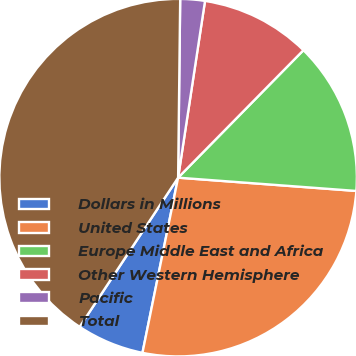Convert chart to OTSL. <chart><loc_0><loc_0><loc_500><loc_500><pie_chart><fcel>Dollars in Millions<fcel>United States<fcel>Europe Middle East and Africa<fcel>Other Western Hemisphere<fcel>Pacific<fcel>Total<nl><fcel>6.09%<fcel>27.01%<fcel>13.82%<fcel>9.96%<fcel>2.22%<fcel>40.9%<nl></chart> 